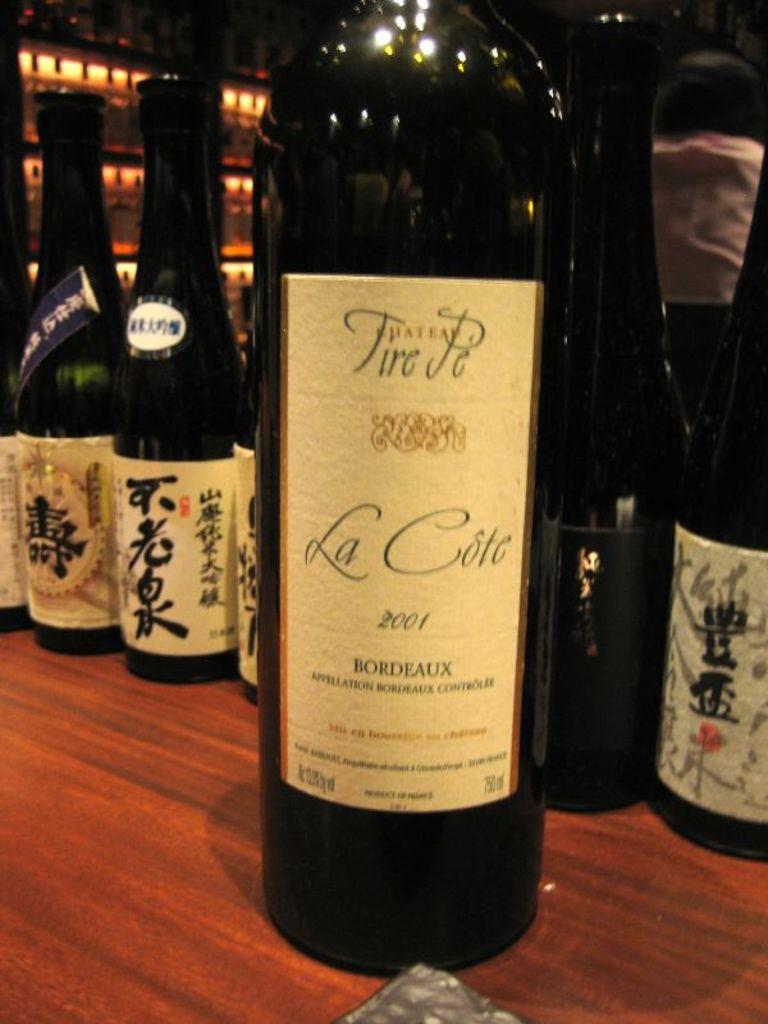Provide a one-sentence caption for the provided image. A wine bottle with the label Chateau Tire Pe, La Cote  2001 Bordeaux on a wood table with other bottles behind it. 